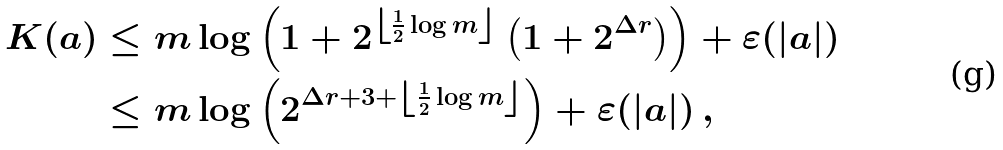Convert formula to latex. <formula><loc_0><loc_0><loc_500><loc_500>K ( a ) & \leq m \log \left ( 1 + 2 ^ { \left \lfloor \frac { 1 } { 2 } \log m \right \rfloor } \left ( 1 + 2 ^ { \Delta r } \right ) \right ) + \varepsilon ( | a | ) \\ & \leq m \log \left ( 2 ^ { \Delta r + 3 + \left \lfloor \frac { 1 } { 2 } \log m \right \rfloor } \right ) + \varepsilon ( | a | ) \, ,</formula> 